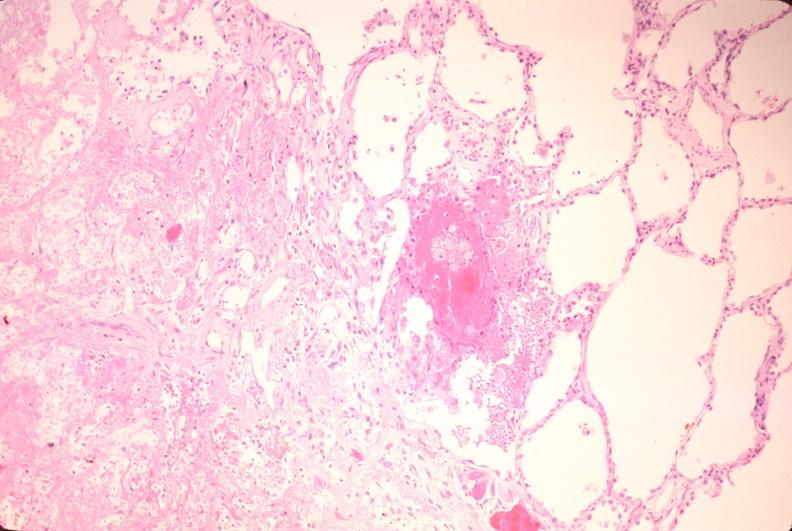s respiratory present?
Answer the question using a single word or phrase. Yes 